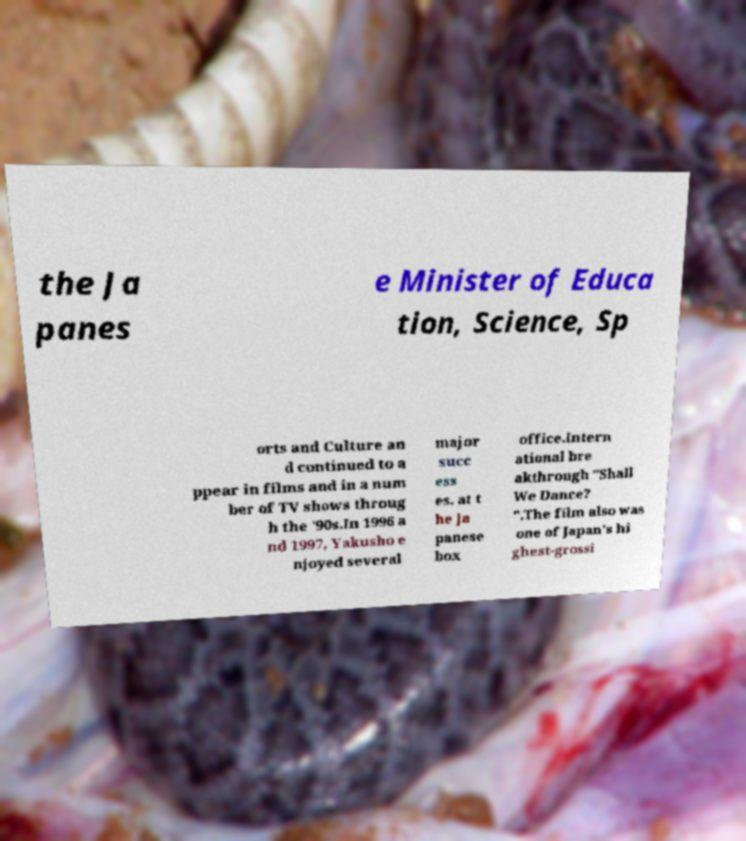Could you assist in decoding the text presented in this image and type it out clearly? the Ja panes e Minister of Educa tion, Science, Sp orts and Culture an d continued to a ppear in films and in a num ber of TV shows throug h the '90s.In 1996 a nd 1997, Yakusho e njoyed several major succ ess es. at t he Ja panese box office.Intern ational bre akthrough "Shall We Dance? ".The film also was one of Japan's hi ghest-grossi 